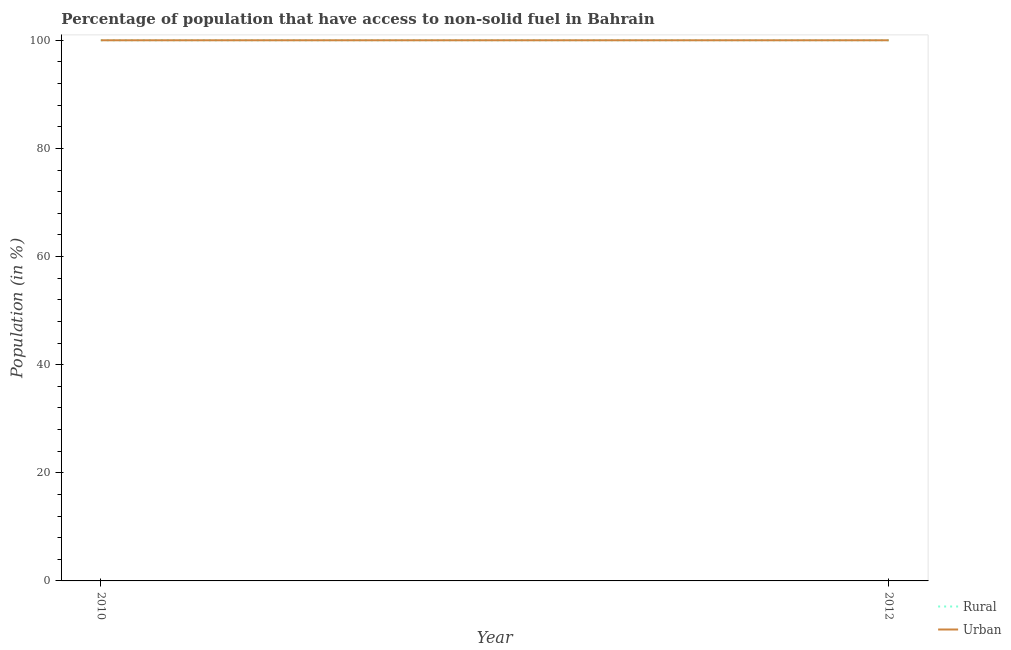Does the line corresponding to urban population intersect with the line corresponding to rural population?
Your response must be concise. Yes. What is the rural population in 2010?
Provide a short and direct response. 100. Across all years, what is the maximum urban population?
Your response must be concise. 100. Across all years, what is the minimum rural population?
Offer a very short reply. 100. In which year was the rural population minimum?
Keep it short and to the point. 2010. What is the total rural population in the graph?
Offer a very short reply. 200. What is the difference between the urban population in 2010 and that in 2012?
Provide a succinct answer. 0. What is the difference between the urban population in 2012 and the rural population in 2010?
Make the answer very short. 0. Is the rural population in 2010 less than that in 2012?
Provide a succinct answer. No. In how many years, is the rural population greater than the average rural population taken over all years?
Ensure brevity in your answer.  0. Does the rural population monotonically increase over the years?
Your answer should be compact. No. How many years are there in the graph?
Ensure brevity in your answer.  2. Where does the legend appear in the graph?
Keep it short and to the point. Bottom right. How many legend labels are there?
Provide a short and direct response. 2. What is the title of the graph?
Offer a very short reply. Percentage of population that have access to non-solid fuel in Bahrain. Does "Secondary education" appear as one of the legend labels in the graph?
Ensure brevity in your answer.  No. What is the label or title of the X-axis?
Keep it short and to the point. Year. Across all years, what is the maximum Population (in %) of Rural?
Your answer should be very brief. 100. Across all years, what is the maximum Population (in %) in Urban?
Your answer should be compact. 100. Across all years, what is the minimum Population (in %) of Rural?
Your answer should be very brief. 100. What is the total Population (in %) in Rural in the graph?
Ensure brevity in your answer.  200. What is the total Population (in %) of Urban in the graph?
Make the answer very short. 200. What is the average Population (in %) of Rural per year?
Offer a terse response. 100. What is the average Population (in %) in Urban per year?
Your response must be concise. 100. What is the ratio of the Population (in %) in Rural in 2010 to that in 2012?
Give a very brief answer. 1. What is the ratio of the Population (in %) of Urban in 2010 to that in 2012?
Offer a terse response. 1. What is the difference between the highest and the second highest Population (in %) of Urban?
Make the answer very short. 0. What is the difference between the highest and the lowest Population (in %) in Rural?
Provide a succinct answer. 0. What is the difference between the highest and the lowest Population (in %) in Urban?
Ensure brevity in your answer.  0. 